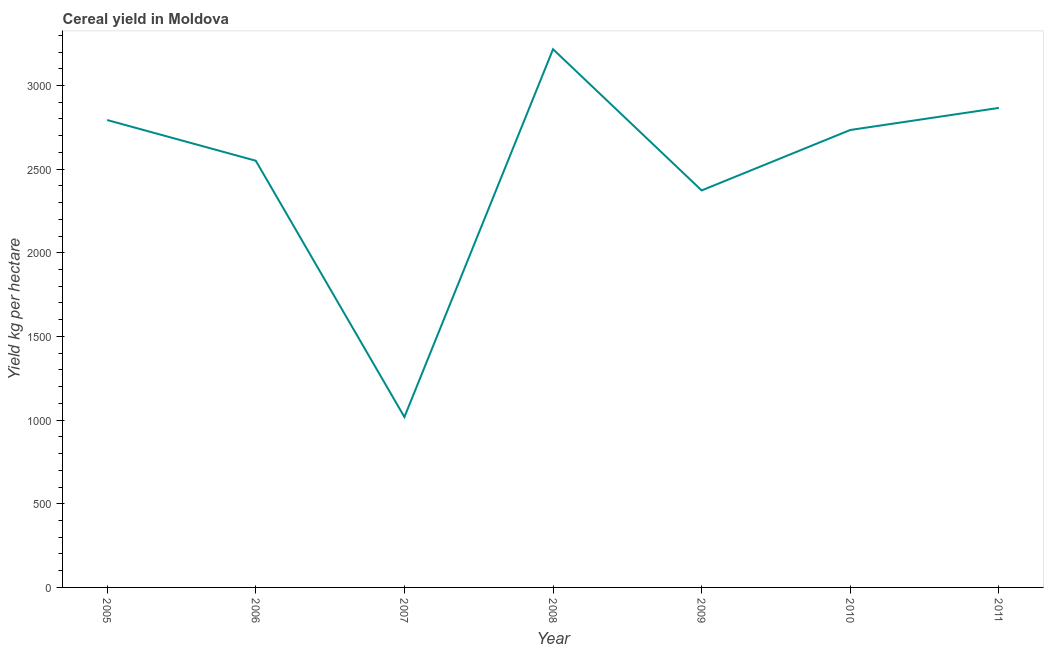What is the cereal yield in 2008?
Your answer should be very brief. 3216.66. Across all years, what is the maximum cereal yield?
Offer a very short reply. 3216.66. Across all years, what is the minimum cereal yield?
Ensure brevity in your answer.  1018.45. In which year was the cereal yield minimum?
Keep it short and to the point. 2007. What is the sum of the cereal yield?
Your answer should be compact. 1.76e+04. What is the difference between the cereal yield in 2006 and 2007?
Make the answer very short. 1531.73. What is the average cereal yield per year?
Ensure brevity in your answer.  2507.33. What is the median cereal yield?
Keep it short and to the point. 2733.99. In how many years, is the cereal yield greater than 100 kg per hectare?
Keep it short and to the point. 7. Do a majority of the years between 2006 and 2007 (inclusive) have cereal yield greater than 1800 kg per hectare?
Provide a short and direct response. No. What is the ratio of the cereal yield in 2009 to that in 2010?
Make the answer very short. 0.87. Is the cereal yield in 2009 less than that in 2010?
Your answer should be compact. Yes. Is the difference between the cereal yield in 2009 and 2011 greater than the difference between any two years?
Ensure brevity in your answer.  No. What is the difference between the highest and the second highest cereal yield?
Give a very brief answer. 350.76. Is the sum of the cereal yield in 2009 and 2011 greater than the maximum cereal yield across all years?
Provide a short and direct response. Yes. What is the difference between the highest and the lowest cereal yield?
Ensure brevity in your answer.  2198.21. How many lines are there?
Keep it short and to the point. 1. Are the values on the major ticks of Y-axis written in scientific E-notation?
Your response must be concise. No. Does the graph contain grids?
Your answer should be compact. No. What is the title of the graph?
Your answer should be very brief. Cereal yield in Moldova. What is the label or title of the Y-axis?
Keep it short and to the point. Yield kg per hectare. What is the Yield kg per hectare of 2005?
Ensure brevity in your answer.  2793.41. What is the Yield kg per hectare of 2006?
Your answer should be very brief. 2550.18. What is the Yield kg per hectare in 2007?
Provide a short and direct response. 1018.45. What is the Yield kg per hectare of 2008?
Ensure brevity in your answer.  3216.66. What is the Yield kg per hectare in 2009?
Your answer should be compact. 2372.73. What is the Yield kg per hectare in 2010?
Your response must be concise. 2733.99. What is the Yield kg per hectare of 2011?
Make the answer very short. 2865.9. What is the difference between the Yield kg per hectare in 2005 and 2006?
Your answer should be compact. 243.22. What is the difference between the Yield kg per hectare in 2005 and 2007?
Give a very brief answer. 1774.96. What is the difference between the Yield kg per hectare in 2005 and 2008?
Make the answer very short. -423.25. What is the difference between the Yield kg per hectare in 2005 and 2009?
Provide a succinct answer. 420.68. What is the difference between the Yield kg per hectare in 2005 and 2010?
Your answer should be compact. 59.41. What is the difference between the Yield kg per hectare in 2005 and 2011?
Ensure brevity in your answer.  -72.5. What is the difference between the Yield kg per hectare in 2006 and 2007?
Your answer should be very brief. 1531.73. What is the difference between the Yield kg per hectare in 2006 and 2008?
Your response must be concise. -666.48. What is the difference between the Yield kg per hectare in 2006 and 2009?
Ensure brevity in your answer.  177.45. What is the difference between the Yield kg per hectare in 2006 and 2010?
Your answer should be compact. -183.81. What is the difference between the Yield kg per hectare in 2006 and 2011?
Provide a short and direct response. -315.72. What is the difference between the Yield kg per hectare in 2007 and 2008?
Make the answer very short. -2198.21. What is the difference between the Yield kg per hectare in 2007 and 2009?
Ensure brevity in your answer.  -1354.28. What is the difference between the Yield kg per hectare in 2007 and 2010?
Provide a short and direct response. -1715.54. What is the difference between the Yield kg per hectare in 2007 and 2011?
Offer a very short reply. -1847.45. What is the difference between the Yield kg per hectare in 2008 and 2009?
Make the answer very short. 843.93. What is the difference between the Yield kg per hectare in 2008 and 2010?
Provide a short and direct response. 482.67. What is the difference between the Yield kg per hectare in 2008 and 2011?
Offer a very short reply. 350.76. What is the difference between the Yield kg per hectare in 2009 and 2010?
Give a very brief answer. -361.26. What is the difference between the Yield kg per hectare in 2009 and 2011?
Provide a succinct answer. -493.17. What is the difference between the Yield kg per hectare in 2010 and 2011?
Offer a very short reply. -131.91. What is the ratio of the Yield kg per hectare in 2005 to that in 2006?
Your answer should be compact. 1.09. What is the ratio of the Yield kg per hectare in 2005 to that in 2007?
Make the answer very short. 2.74. What is the ratio of the Yield kg per hectare in 2005 to that in 2008?
Your response must be concise. 0.87. What is the ratio of the Yield kg per hectare in 2005 to that in 2009?
Give a very brief answer. 1.18. What is the ratio of the Yield kg per hectare in 2006 to that in 2007?
Keep it short and to the point. 2.5. What is the ratio of the Yield kg per hectare in 2006 to that in 2008?
Offer a very short reply. 0.79. What is the ratio of the Yield kg per hectare in 2006 to that in 2009?
Make the answer very short. 1.07. What is the ratio of the Yield kg per hectare in 2006 to that in 2010?
Keep it short and to the point. 0.93. What is the ratio of the Yield kg per hectare in 2006 to that in 2011?
Your answer should be very brief. 0.89. What is the ratio of the Yield kg per hectare in 2007 to that in 2008?
Your answer should be compact. 0.32. What is the ratio of the Yield kg per hectare in 2007 to that in 2009?
Keep it short and to the point. 0.43. What is the ratio of the Yield kg per hectare in 2007 to that in 2010?
Keep it short and to the point. 0.37. What is the ratio of the Yield kg per hectare in 2007 to that in 2011?
Provide a succinct answer. 0.35. What is the ratio of the Yield kg per hectare in 2008 to that in 2009?
Your answer should be compact. 1.36. What is the ratio of the Yield kg per hectare in 2008 to that in 2010?
Offer a terse response. 1.18. What is the ratio of the Yield kg per hectare in 2008 to that in 2011?
Give a very brief answer. 1.12. What is the ratio of the Yield kg per hectare in 2009 to that in 2010?
Offer a very short reply. 0.87. What is the ratio of the Yield kg per hectare in 2009 to that in 2011?
Provide a succinct answer. 0.83. What is the ratio of the Yield kg per hectare in 2010 to that in 2011?
Your response must be concise. 0.95. 